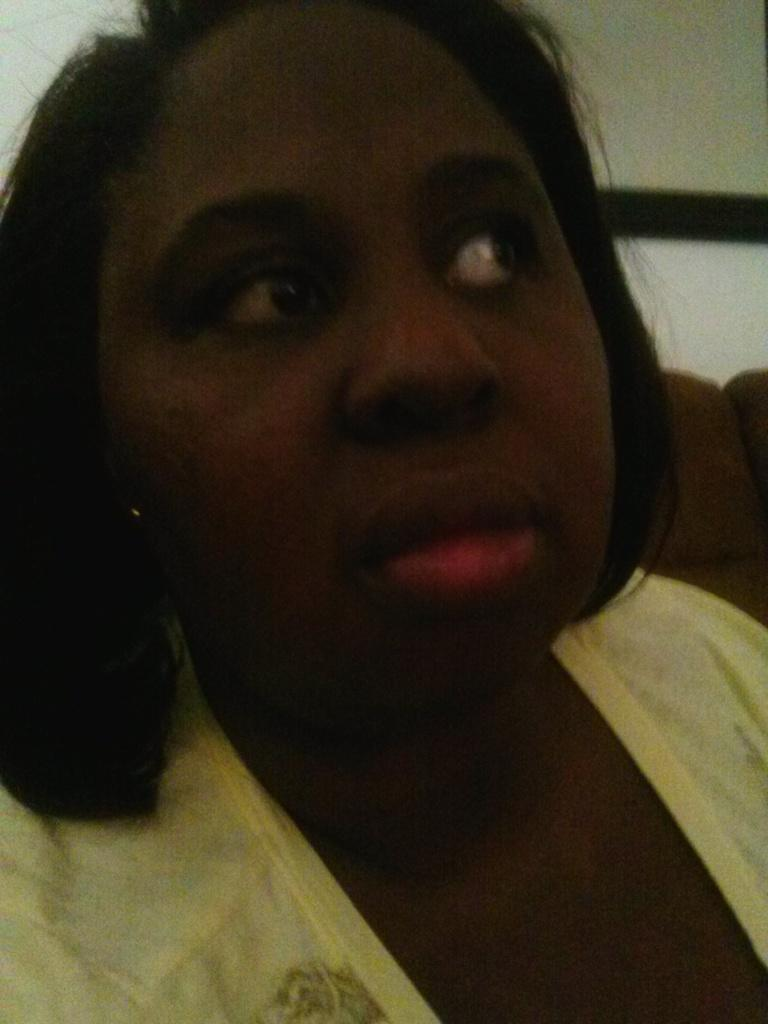Who is present in the image? There is a woman in the image. What can be seen in the background of the image? There is a wall in the background of the image. Reasoning: Let' Let's think step by step in order to produce the conversation. We start by identifying the main subject in the image, which is the woman. Then, we expand the conversation to include the background of the image, which features a wall. Each question is designed to elicit a specific detail about the image that is known from the provided facts. Absurd Question/Answer: What type of business is the woman running in the image? There is no indication of a business in the image; it only features a woman and a wall in the background. 